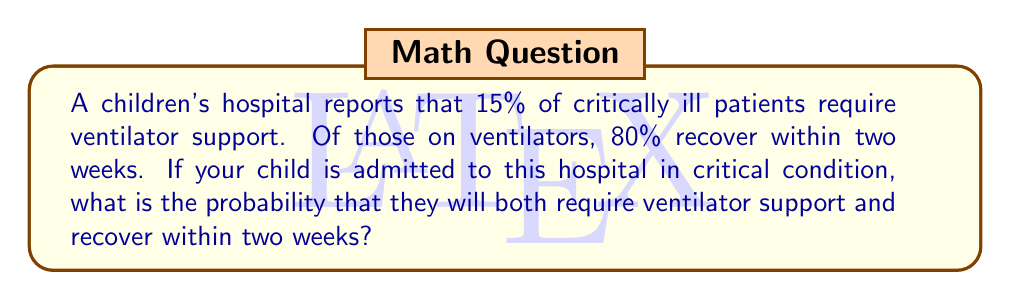Can you solve this math problem? Let's approach this step-by-step:

1) First, we need to identify the two events:
   A: The child requires ventilator support
   B: The child recovers within two weeks (given that they are on a ventilator)

2) We're given the following probabilities:
   $P(A) = 15\% = 0.15$ (probability of requiring ventilator support)
   $P(B|A) = 80\% = 0.80$ (probability of recovering within two weeks, given that the child is on a ventilator)

3) We want to find the probability of both A and B occurring. This is a joint probability, which can be calculated using the multiplication rule:

   $P(A \text{ and } B) = P(A) \times P(B|A)$

4) Substituting the values:

   $P(A \text{ and } B) = 0.15 \times 0.80$

5) Calculating:

   $P(A \text{ and } B) = 0.12$

6) Converting to a percentage:

   $0.12 \times 100\% = 12\%$

Therefore, the probability that your child will both require ventilator support and recover within two weeks is 12%.
Answer: 12% 